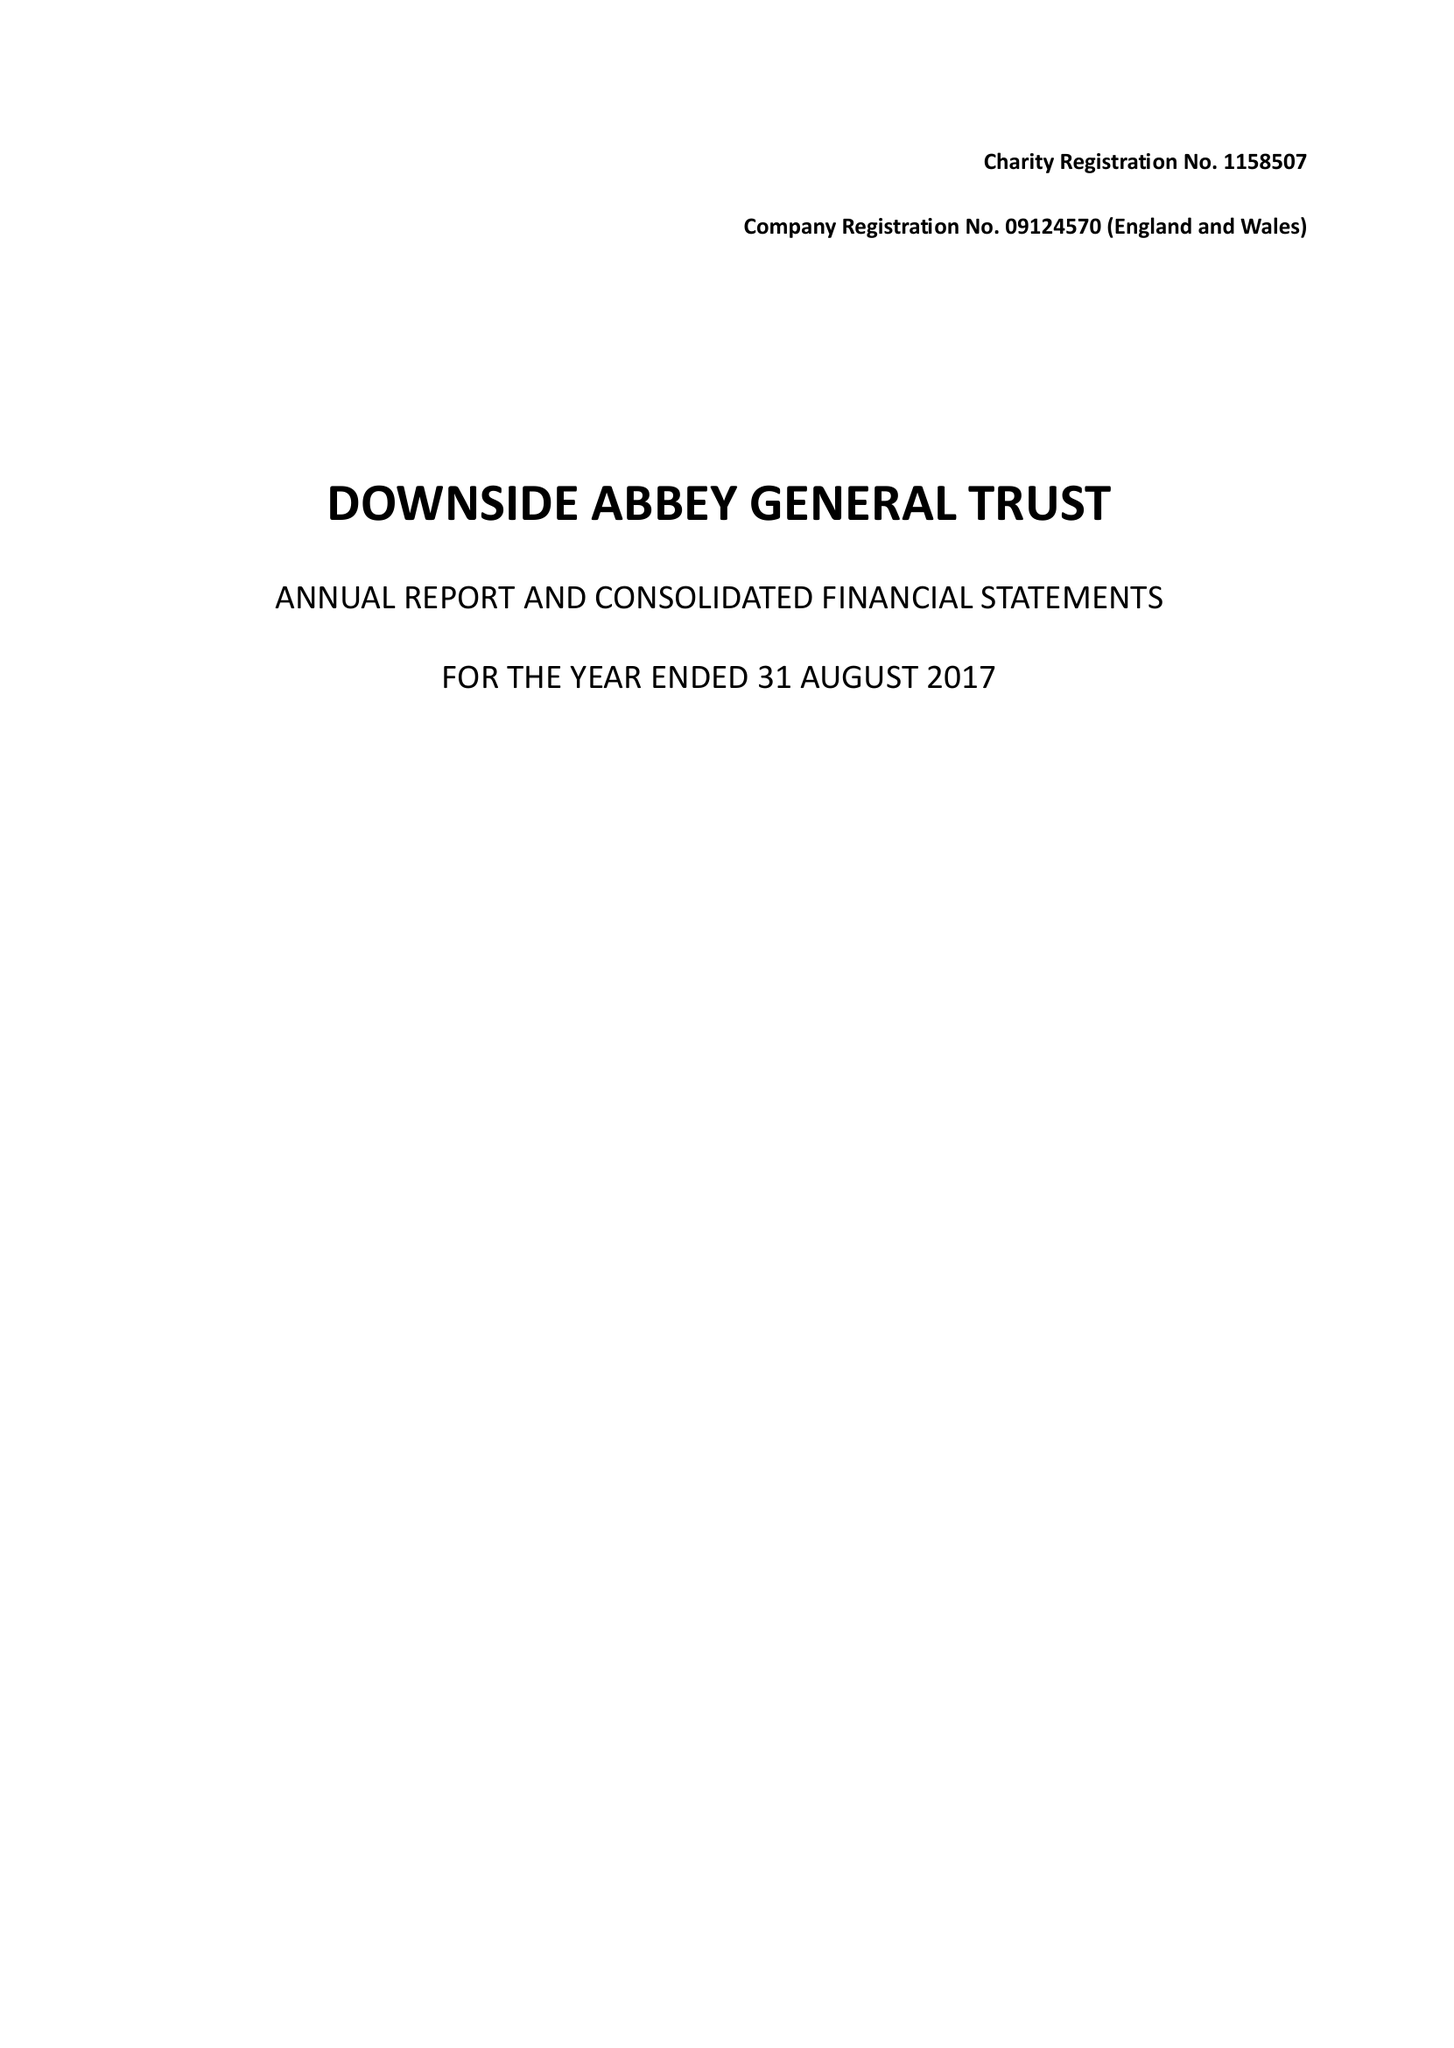What is the value for the spending_annually_in_british_pounds?
Answer the question using a single word or phrase. 10348420.00 